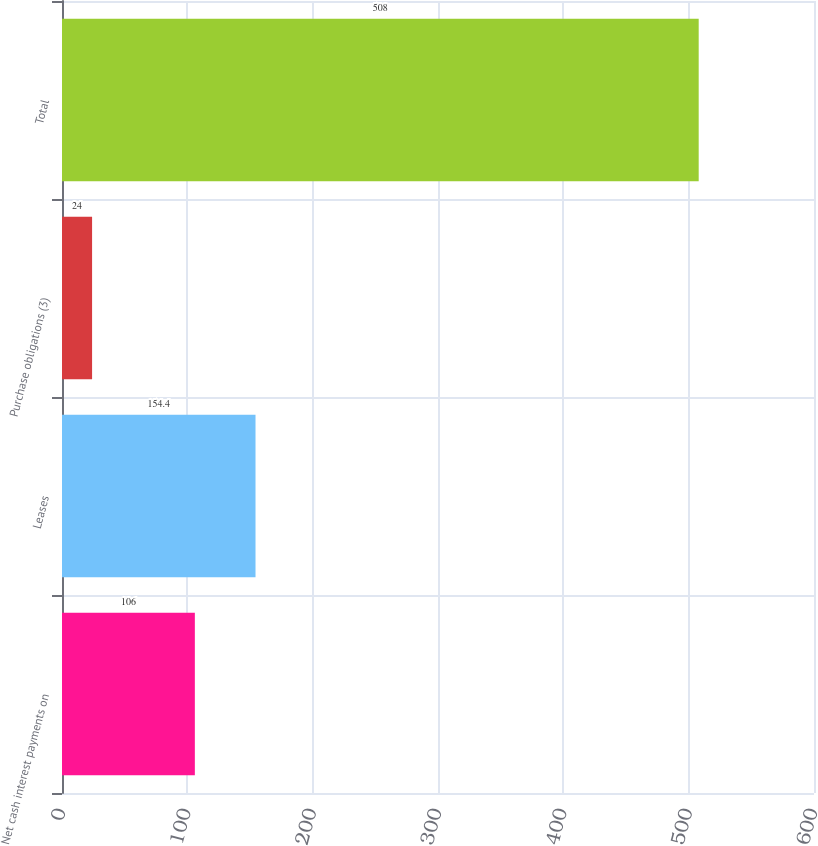<chart> <loc_0><loc_0><loc_500><loc_500><bar_chart><fcel>Net cash interest payments on<fcel>Leases<fcel>Purchase obligations (3)<fcel>Total<nl><fcel>106<fcel>154.4<fcel>24<fcel>508<nl></chart> 